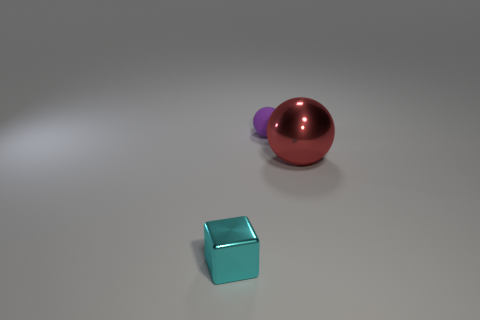Can you infer any specific theme or message from the arrangement of these objects? While interpretations may vary, one could infer a theme of simplicity and minimalism from the arrangement. The clean background and the modest number of objects could evoke a sense of order and tranquility. The arrangement may also suggest a study in geometry and color balance, drawing the viewer's eye across the differing shapes and hues. 